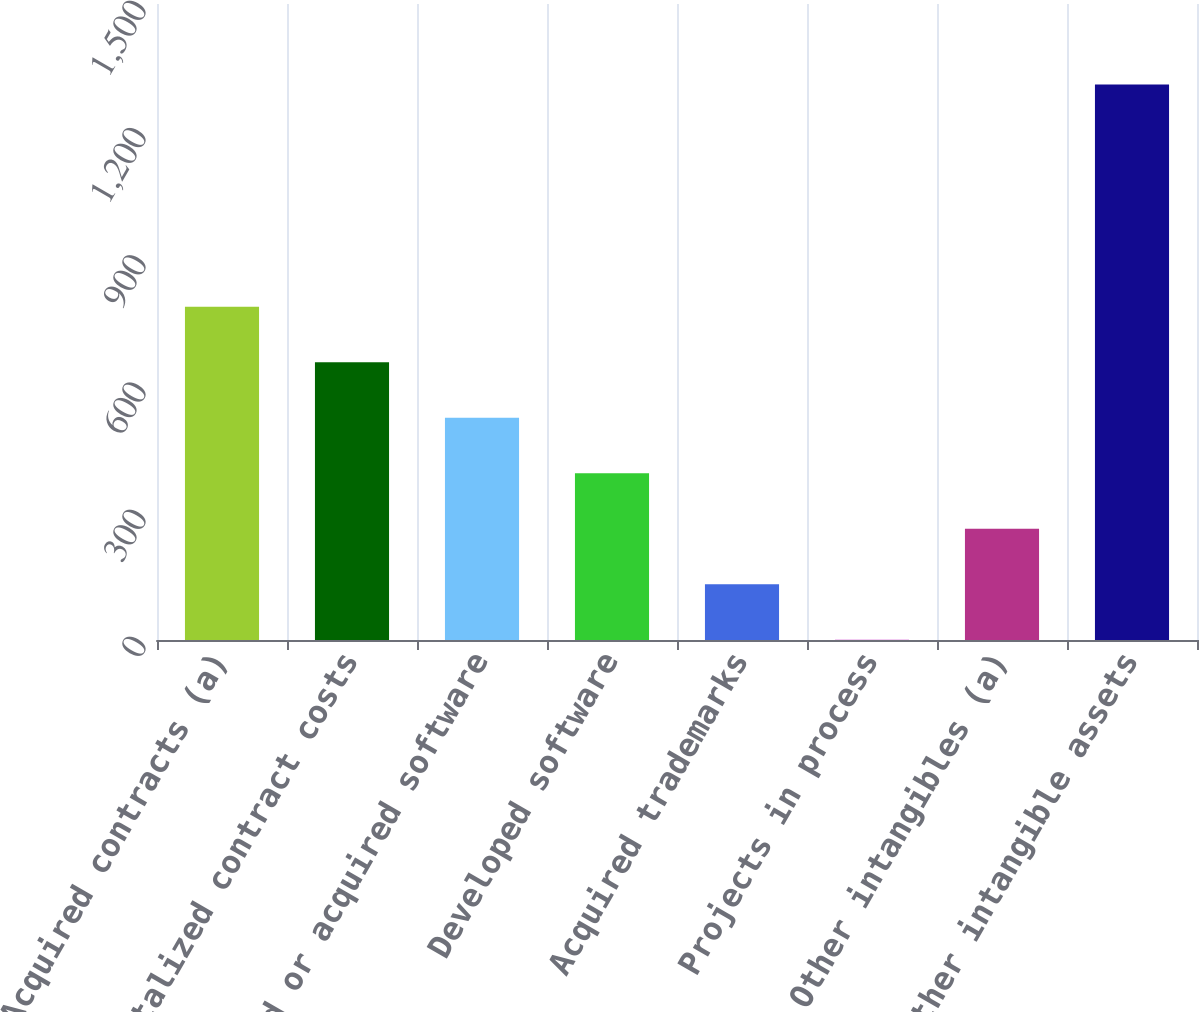Convert chart. <chart><loc_0><loc_0><loc_500><loc_500><bar_chart><fcel>Acquired contracts (a)<fcel>Capitalized contract costs<fcel>Purchased or acquired software<fcel>Developed software<fcel>Acquired trademarks<fcel>Projects in process<fcel>Other intangibles (a)<fcel>Total other intangible assets<nl><fcel>786.26<fcel>655.35<fcel>524.44<fcel>393.53<fcel>131.71<fcel>0.8<fcel>262.62<fcel>1309.9<nl></chart> 